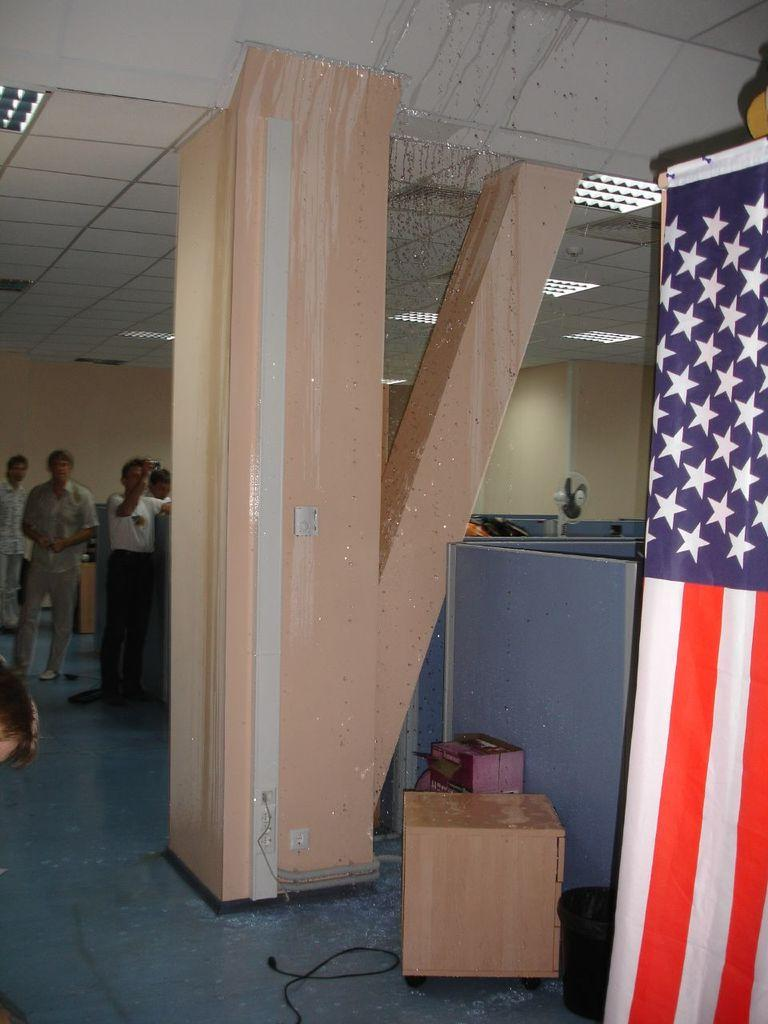What is the main structure in the center of the image? There is a pillar in the center of the image. What can be seen in the background of the image? There are people standing in the background of the image. What object is located at the bottom of the image? There is a box at the bottom of the image. What is the symbolic object in the image? There is a flag in the image. How many boats are visible in the image? There are no boats present in the image. What type of bird can be seen perched on the pillar in the image? There is no bird, specifically a robin, present in the image. 